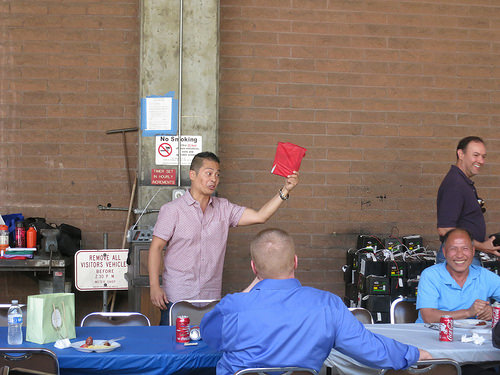<image>
Is the can on the table? Yes. Looking at the image, I can see the can is positioned on top of the table, with the table providing support. Is the sign behind the man? Yes. From this viewpoint, the sign is positioned behind the man, with the man partially or fully occluding the sign. 